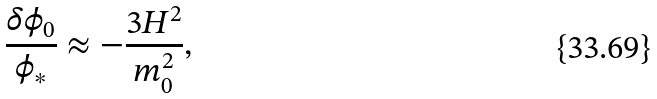Convert formula to latex. <formula><loc_0><loc_0><loc_500><loc_500>\frac { \delta \phi _ { 0 } } { \phi _ { * } } \approx - \frac { 3 H ^ { 2 } } { m _ { 0 } ^ { 2 } } ,</formula> 